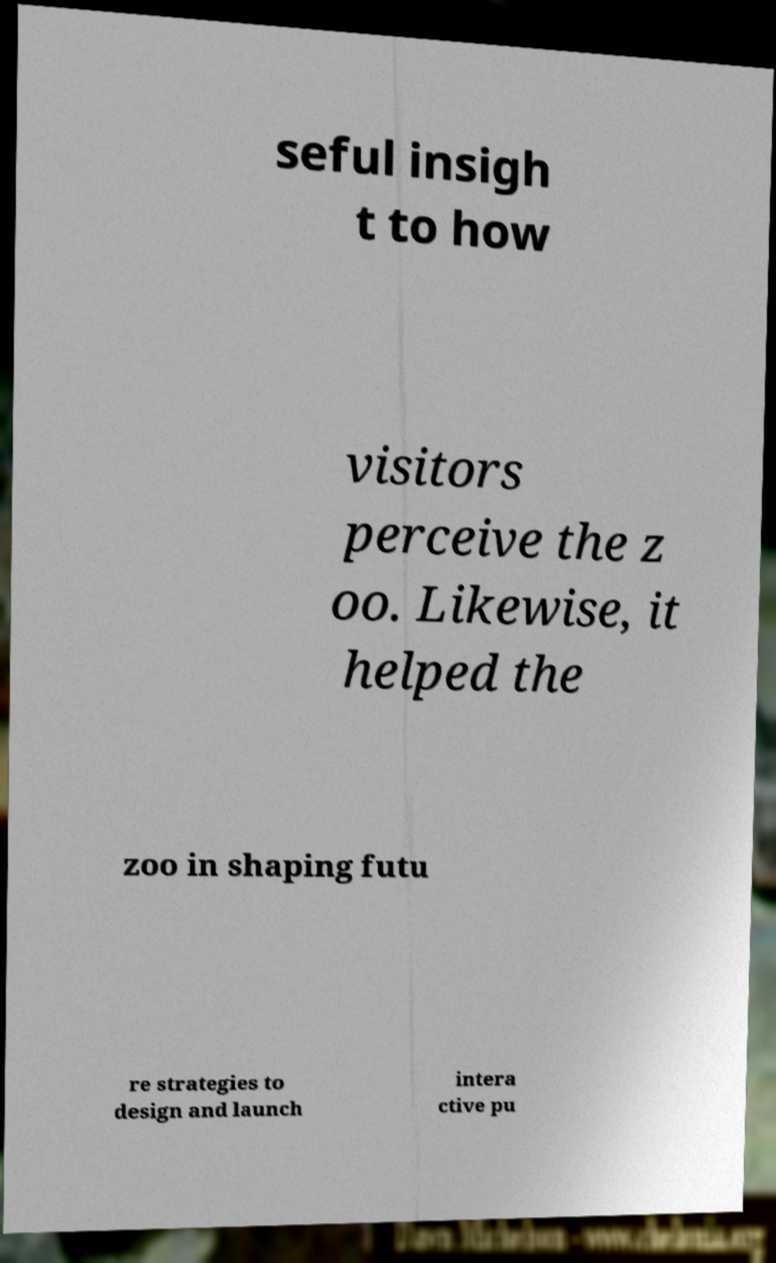Could you extract and type out the text from this image? seful insigh t to how visitors perceive the z oo. Likewise, it helped the zoo in shaping futu re strategies to design and launch intera ctive pu 